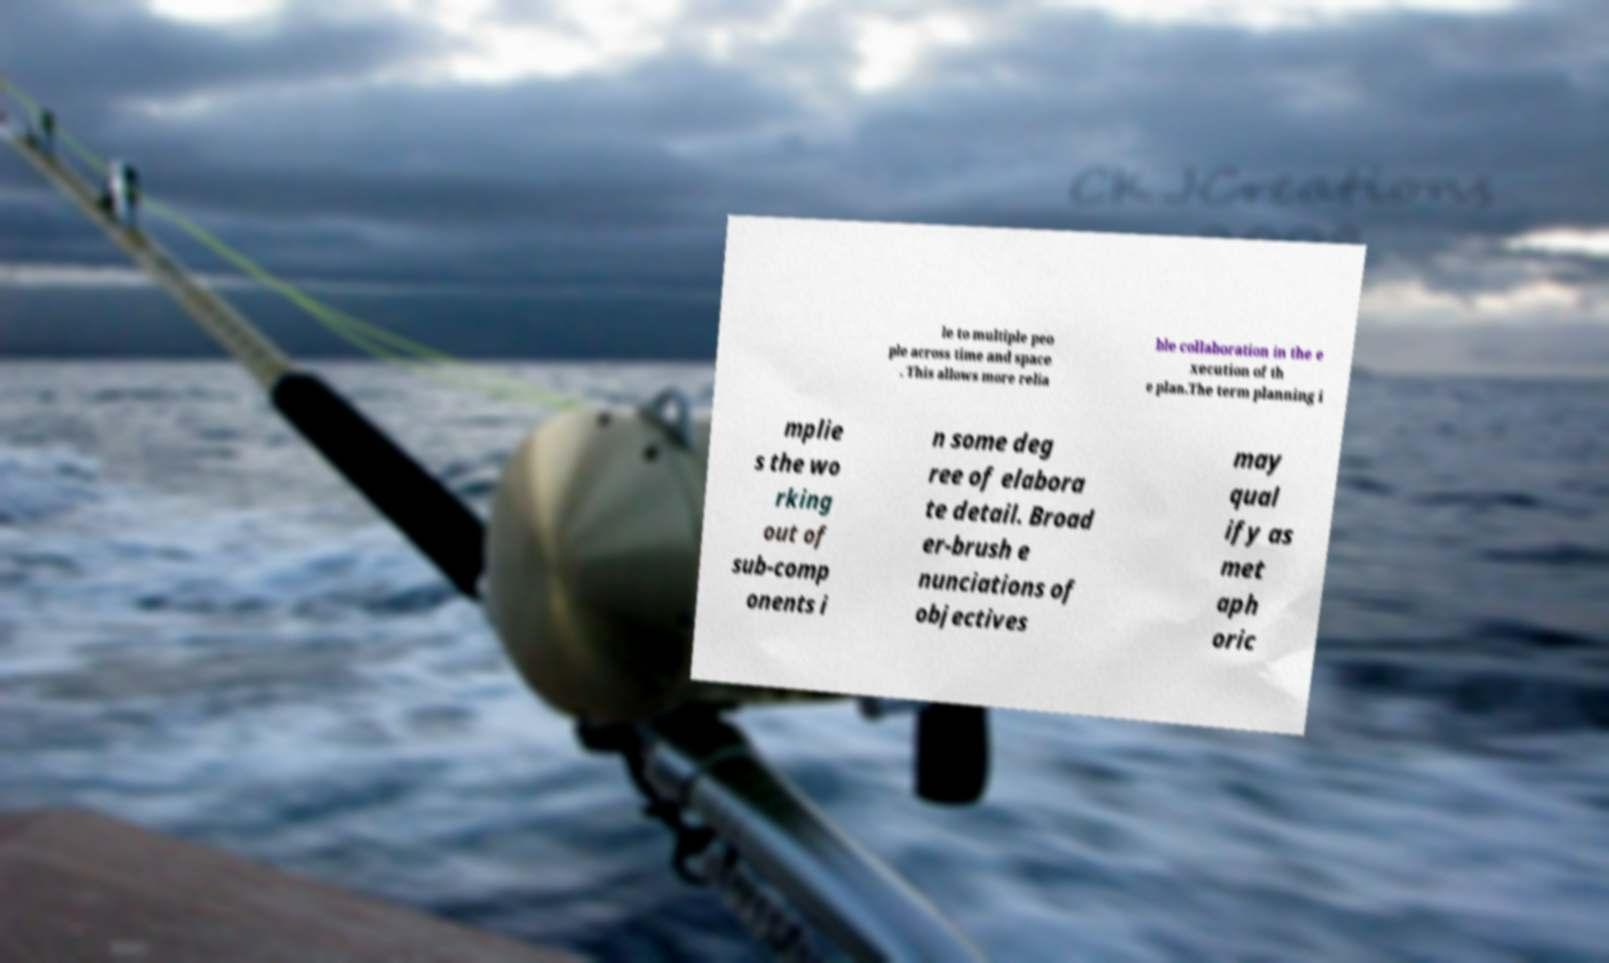For documentation purposes, I need the text within this image transcribed. Could you provide that? le to multiple peo ple across time and space . This allows more relia ble collaboration in the e xecution of th e plan.The term planning i mplie s the wo rking out of sub-comp onents i n some deg ree of elabora te detail. Broad er-brush e nunciations of objectives may qual ify as met aph oric 